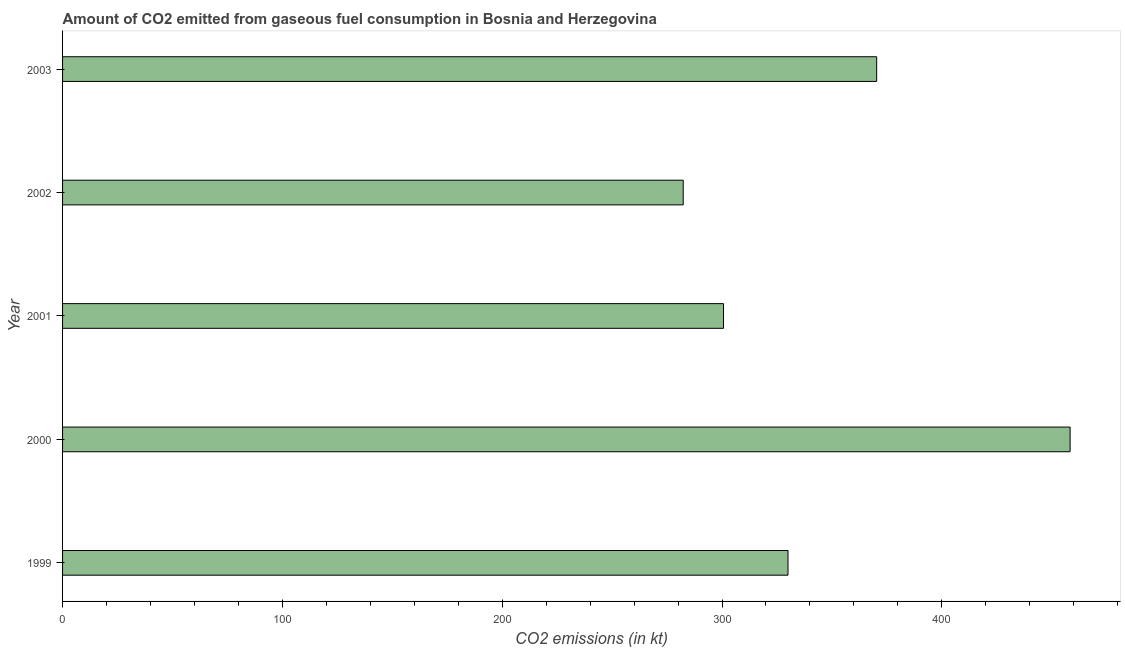Does the graph contain any zero values?
Ensure brevity in your answer.  No. Does the graph contain grids?
Your answer should be very brief. No. What is the title of the graph?
Keep it short and to the point. Amount of CO2 emitted from gaseous fuel consumption in Bosnia and Herzegovina. What is the label or title of the X-axis?
Provide a short and direct response. CO2 emissions (in kt). What is the co2 emissions from gaseous fuel consumption in 2002?
Offer a very short reply. 282.36. Across all years, what is the maximum co2 emissions from gaseous fuel consumption?
Ensure brevity in your answer.  458.38. Across all years, what is the minimum co2 emissions from gaseous fuel consumption?
Your response must be concise. 282.36. What is the sum of the co2 emissions from gaseous fuel consumption?
Offer a very short reply. 1741.83. What is the difference between the co2 emissions from gaseous fuel consumption in 2001 and 2003?
Make the answer very short. -69.67. What is the average co2 emissions from gaseous fuel consumption per year?
Provide a succinct answer. 348.37. What is the median co2 emissions from gaseous fuel consumption?
Provide a short and direct response. 330.03. In how many years, is the co2 emissions from gaseous fuel consumption greater than 200 kt?
Offer a terse response. 5. Do a majority of the years between 2002 and 2003 (inclusive) have co2 emissions from gaseous fuel consumption greater than 220 kt?
Offer a very short reply. Yes. What is the ratio of the co2 emissions from gaseous fuel consumption in 1999 to that in 2000?
Offer a very short reply. 0.72. Is the co2 emissions from gaseous fuel consumption in 1999 less than that in 2000?
Offer a very short reply. Yes. Is the difference between the co2 emissions from gaseous fuel consumption in 1999 and 2003 greater than the difference between any two years?
Provide a short and direct response. No. What is the difference between the highest and the second highest co2 emissions from gaseous fuel consumption?
Your response must be concise. 88.01. Is the sum of the co2 emissions from gaseous fuel consumption in 2001 and 2002 greater than the maximum co2 emissions from gaseous fuel consumption across all years?
Provide a succinct answer. Yes. What is the difference between the highest and the lowest co2 emissions from gaseous fuel consumption?
Offer a terse response. 176.02. In how many years, is the co2 emissions from gaseous fuel consumption greater than the average co2 emissions from gaseous fuel consumption taken over all years?
Provide a succinct answer. 2. How many bars are there?
Ensure brevity in your answer.  5. What is the difference between two consecutive major ticks on the X-axis?
Give a very brief answer. 100. What is the CO2 emissions (in kt) in 1999?
Your response must be concise. 330.03. What is the CO2 emissions (in kt) of 2000?
Provide a short and direct response. 458.38. What is the CO2 emissions (in kt) of 2001?
Keep it short and to the point. 300.69. What is the CO2 emissions (in kt) of 2002?
Provide a short and direct response. 282.36. What is the CO2 emissions (in kt) of 2003?
Your answer should be very brief. 370.37. What is the difference between the CO2 emissions (in kt) in 1999 and 2000?
Your answer should be very brief. -128.34. What is the difference between the CO2 emissions (in kt) in 1999 and 2001?
Provide a succinct answer. 29.34. What is the difference between the CO2 emissions (in kt) in 1999 and 2002?
Keep it short and to the point. 47.67. What is the difference between the CO2 emissions (in kt) in 1999 and 2003?
Your answer should be very brief. -40.34. What is the difference between the CO2 emissions (in kt) in 2000 and 2001?
Offer a terse response. 157.68. What is the difference between the CO2 emissions (in kt) in 2000 and 2002?
Make the answer very short. 176.02. What is the difference between the CO2 emissions (in kt) in 2000 and 2003?
Offer a very short reply. 88.01. What is the difference between the CO2 emissions (in kt) in 2001 and 2002?
Ensure brevity in your answer.  18.34. What is the difference between the CO2 emissions (in kt) in 2001 and 2003?
Ensure brevity in your answer.  -69.67. What is the difference between the CO2 emissions (in kt) in 2002 and 2003?
Your answer should be very brief. -88.01. What is the ratio of the CO2 emissions (in kt) in 1999 to that in 2000?
Keep it short and to the point. 0.72. What is the ratio of the CO2 emissions (in kt) in 1999 to that in 2001?
Make the answer very short. 1.1. What is the ratio of the CO2 emissions (in kt) in 1999 to that in 2002?
Give a very brief answer. 1.17. What is the ratio of the CO2 emissions (in kt) in 1999 to that in 2003?
Keep it short and to the point. 0.89. What is the ratio of the CO2 emissions (in kt) in 2000 to that in 2001?
Ensure brevity in your answer.  1.52. What is the ratio of the CO2 emissions (in kt) in 2000 to that in 2002?
Give a very brief answer. 1.62. What is the ratio of the CO2 emissions (in kt) in 2000 to that in 2003?
Ensure brevity in your answer.  1.24. What is the ratio of the CO2 emissions (in kt) in 2001 to that in 2002?
Your answer should be very brief. 1.06. What is the ratio of the CO2 emissions (in kt) in 2001 to that in 2003?
Your answer should be very brief. 0.81. What is the ratio of the CO2 emissions (in kt) in 2002 to that in 2003?
Your answer should be compact. 0.76. 